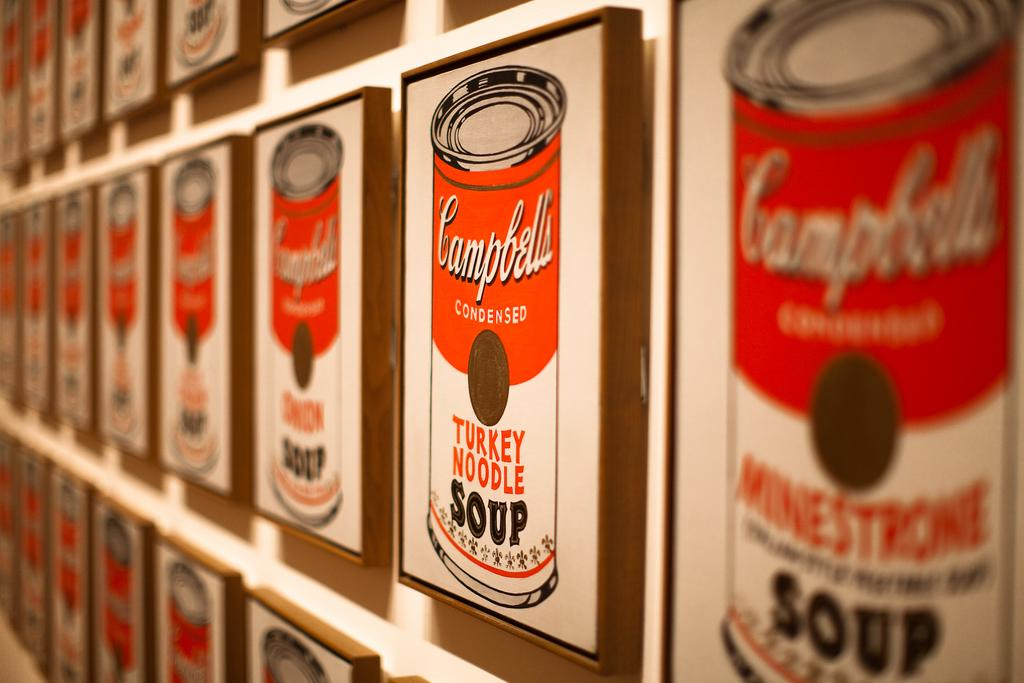<image>
Provide a brief description of the given image. the word Campbell is on the red and white soup 